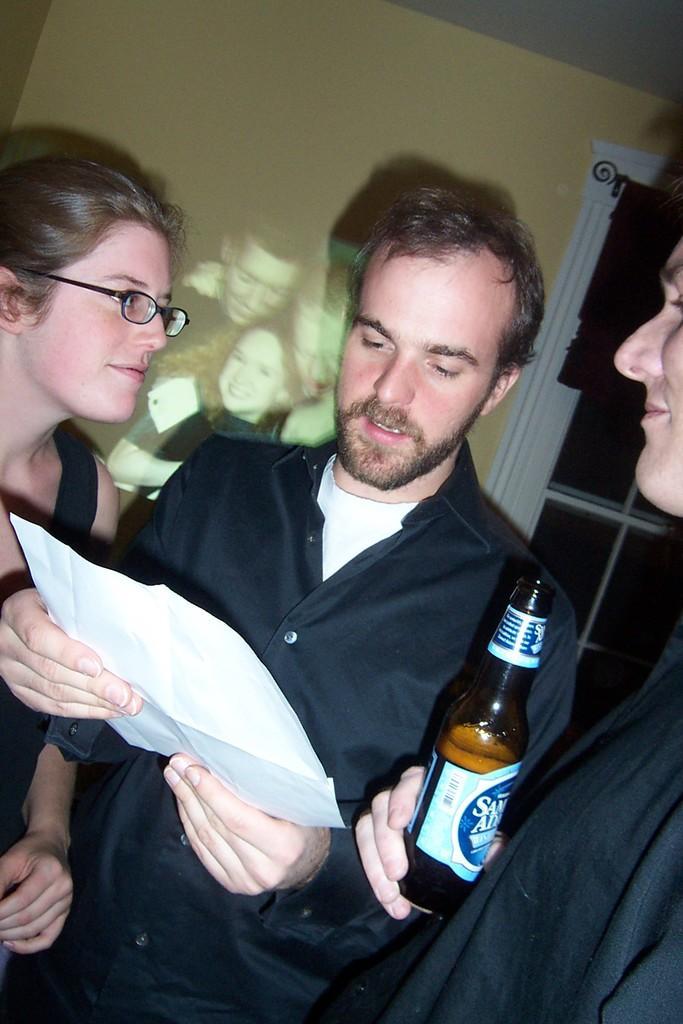Please provide a concise description of this image. In this image there are three persons. The person in the middle is holding the paper and the person at the right side is holding the bottle. At the back there is a window. 